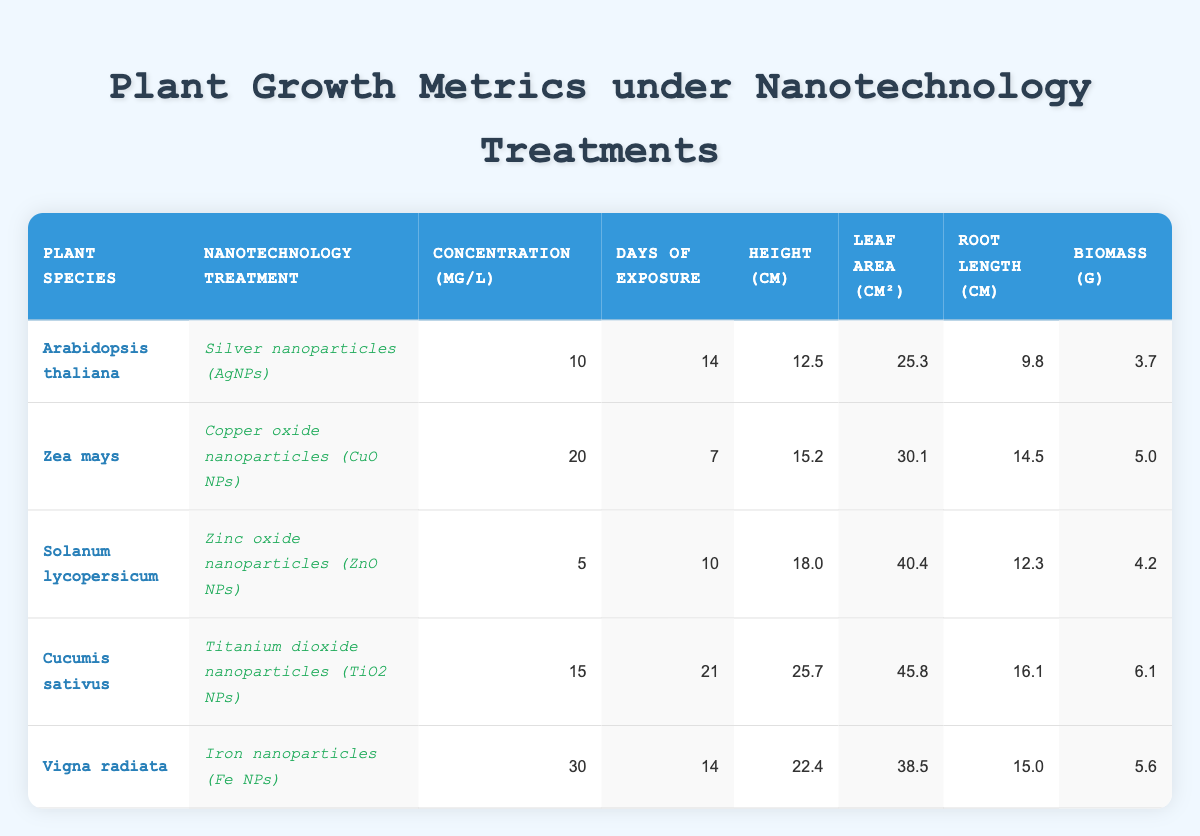What is the height of Cucumis sativus under Titanium dioxide nanoparticles treatment? The height of Cucumis sativus is listed in the table under the respective treatment column, which shows a height of 25.7 cm.
Answer: 25.7 cm Which plant species has the largest leaf area? By comparing the leaf area values from all the rows, Cucumis sativus has the largest leaf area of 45.8 cm².
Answer: Cucumis sativus What is the average root length of all the plant species tested? To find the average root length, sum the root lengths: (9.8 + 14.5 + 12.3 + 16.1 + 15.0) = 67.7 cm. There are 5 species, so the average is 67.7/5 = 13.54 cm.
Answer: 13.54 cm Was the concentration of nanotechnology treatment highest for Vigna radiata? The concentration for Vigna radiata is 30 mg/L. Comparing this with other concentrations, it is indeed the highest among them.
Answer: Yes How does the biomass of Arabidopsis thaliana compare to the average biomass of all the plants? The biomass of Arabidopsis thaliana is 3.7 g. First, calculate the average biomass: (3.7 + 5.0 + 4.2 + 6.1 + 5.6) = 24.6 g. The average is 24.6/5 = 4.92 g. Comparing 3.7 g to 4.92 g shows that it is lower.
Answer: Lower 